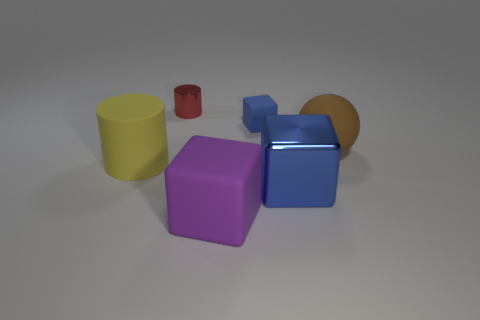Can you tell me about the lighting in this image? Is it coming from multiple sources? The lighting in the image appears to be uniform, suggesting it's coming from a single diffuse source. There aren't any harsh shadows or highlights that would indicate multiple light sources. 